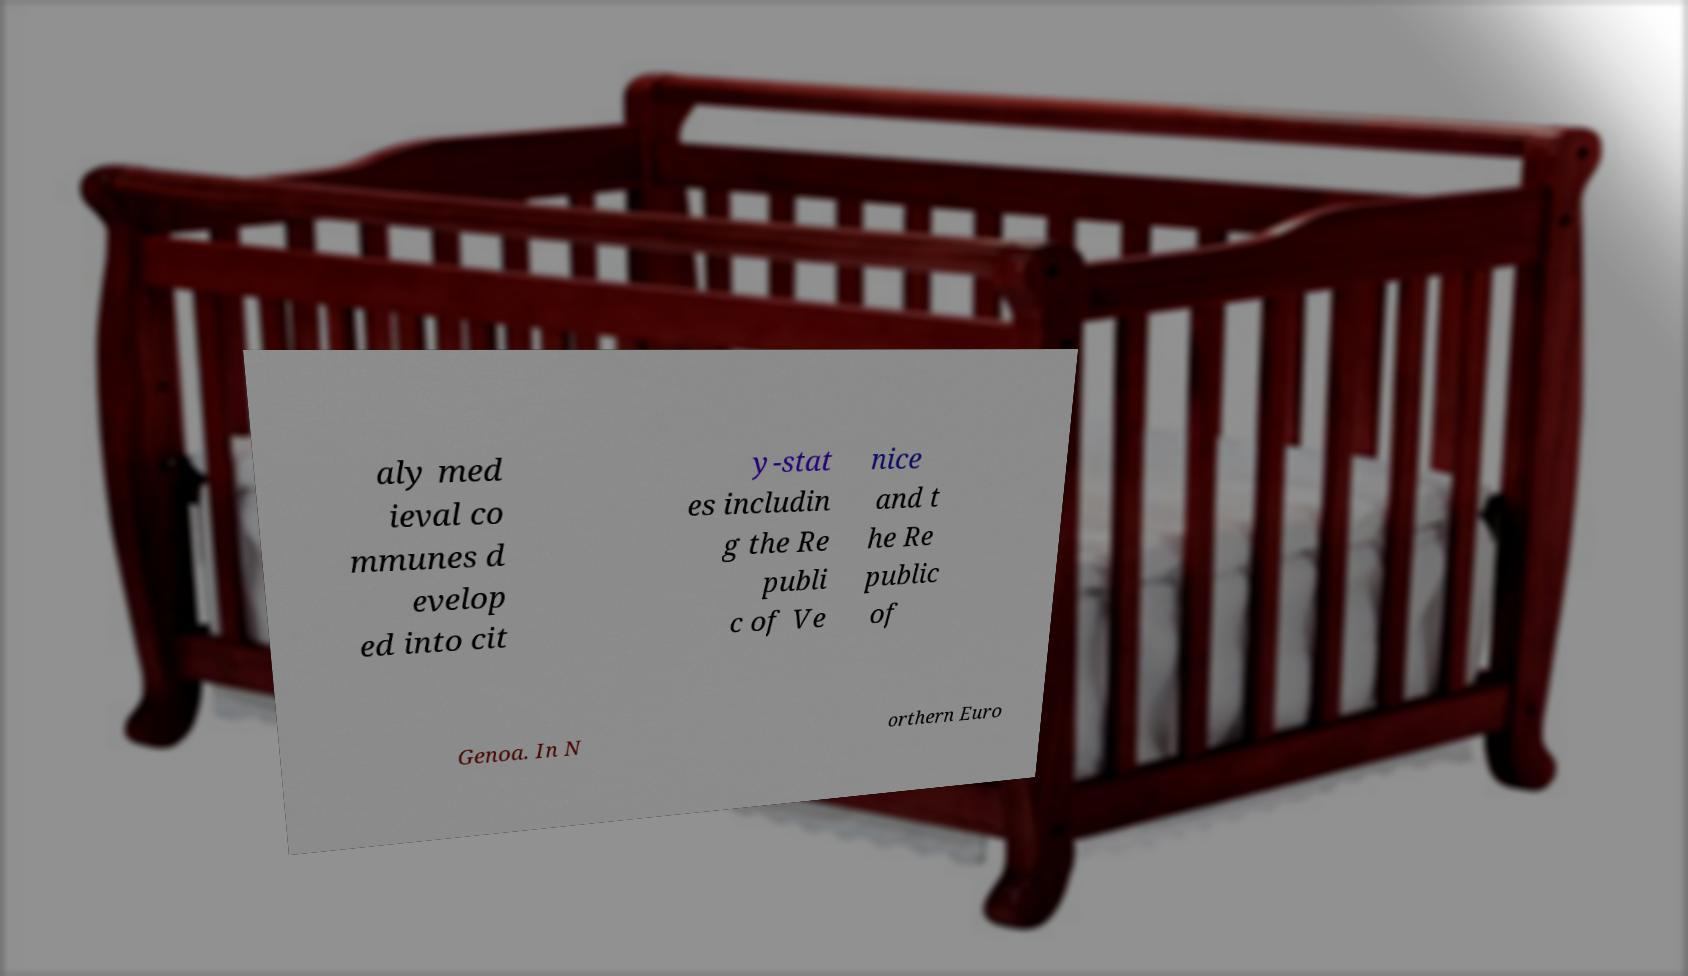What messages or text are displayed in this image? I need them in a readable, typed format. aly med ieval co mmunes d evelop ed into cit y-stat es includin g the Re publi c of Ve nice and t he Re public of Genoa. In N orthern Euro 